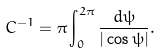<formula> <loc_0><loc_0><loc_500><loc_500>C ^ { - 1 } = \pi \int _ { 0 } ^ { 2 \pi } \frac { d \psi } { | \cos \psi | } .</formula> 